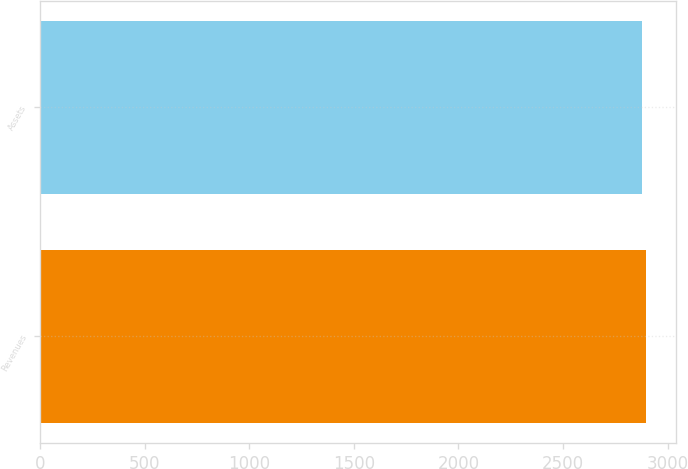Convert chart to OTSL. <chart><loc_0><loc_0><loc_500><loc_500><bar_chart><fcel>Revenues<fcel>Assets<nl><fcel>2897<fcel>2879.8<nl></chart> 